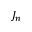Convert formula to latex. <formula><loc_0><loc_0><loc_500><loc_500>J _ { n }</formula> 